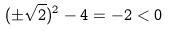Convert formula to latex. <formula><loc_0><loc_0><loc_500><loc_500>( \pm \sqrt { 2 } ) ^ { 2 } - 4 = - 2 < 0</formula> 